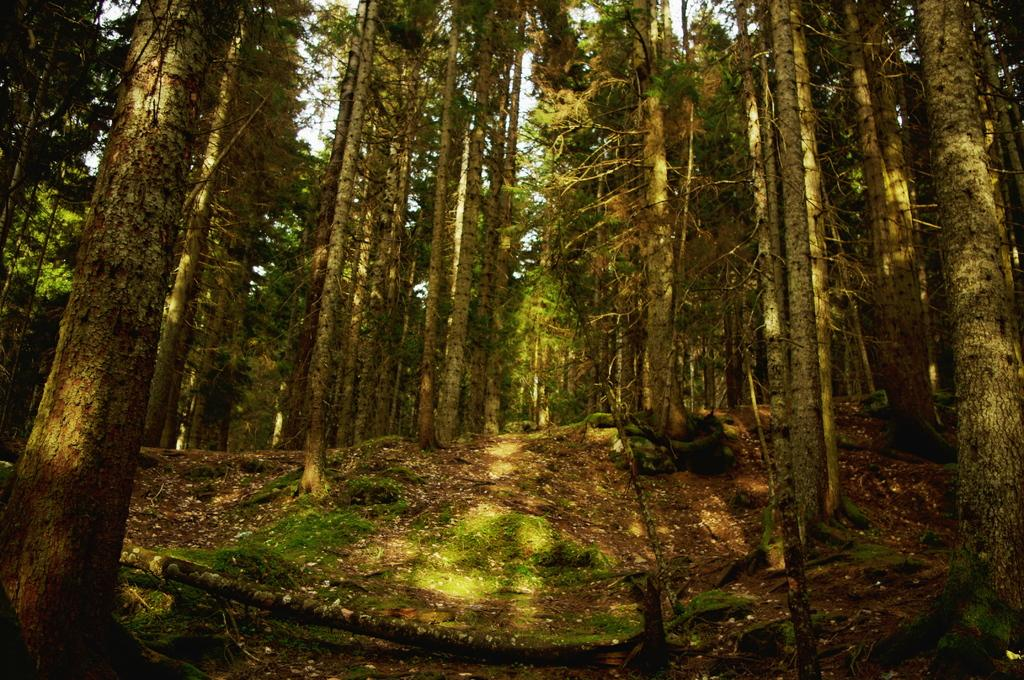What type of vegetation can be seen in the image? There is a group of trees in the image. What part of the natural environment is visible in the image? The sky is visible in the image. What type of weather can be seen in the image? There is no specific weather condition visible in the image; only the sky is visible. Can you see a shelf in the image? There is no shelf present in the image. 